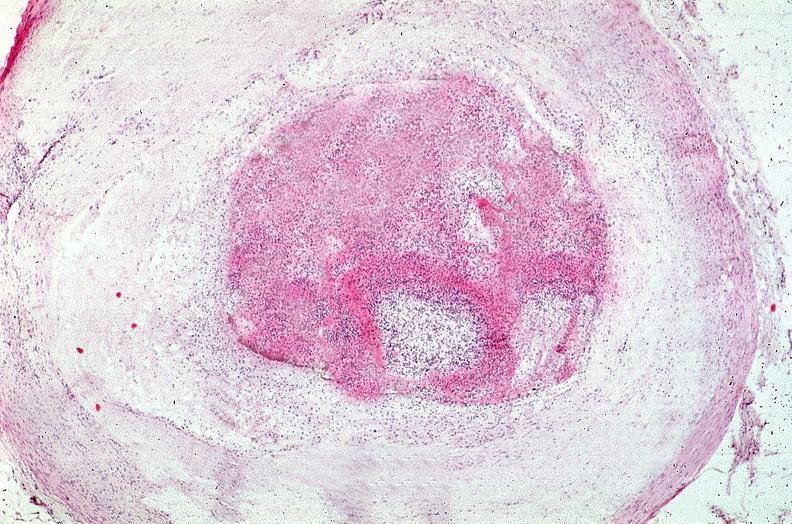s very good example present?
Answer the question using a single word or phrase. No 